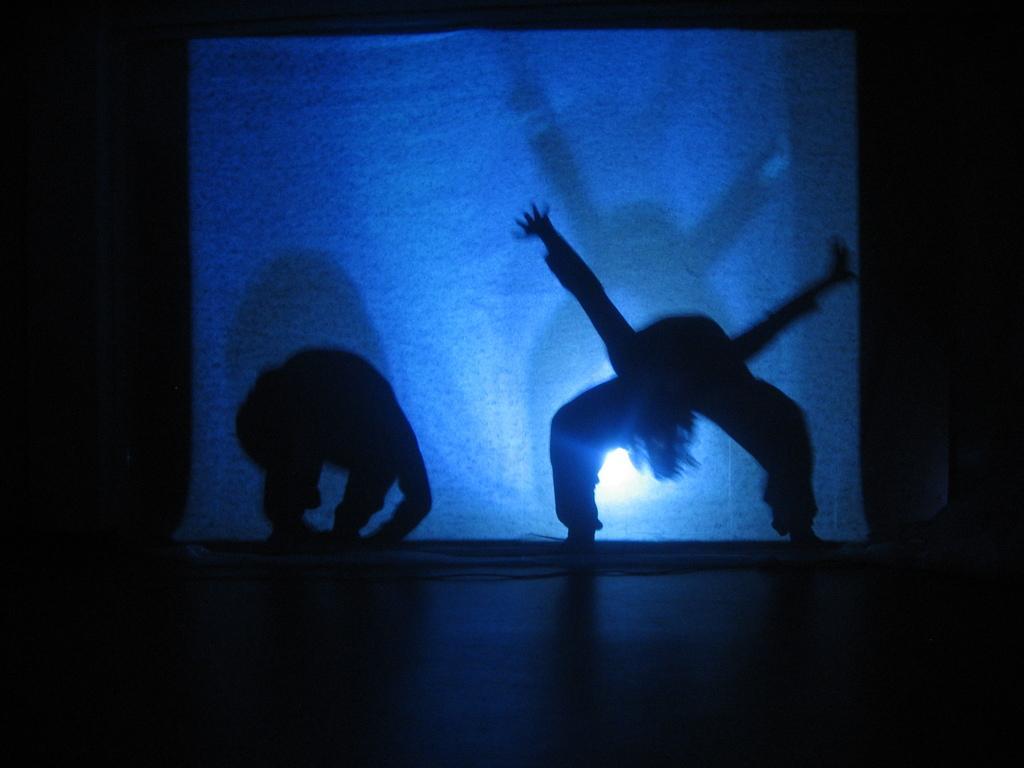Describe this image in one or two sentences. In the picture I can see two persons and looks like they are dancing. In the background, I can see the white screen. 